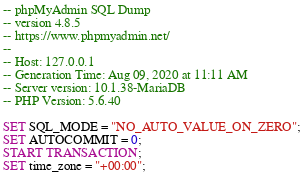<code> <loc_0><loc_0><loc_500><loc_500><_SQL_>-- phpMyAdmin SQL Dump
-- version 4.8.5
-- https://www.phpmyadmin.net/
--
-- Host: 127.0.0.1
-- Generation Time: Aug 09, 2020 at 11:11 AM
-- Server version: 10.1.38-MariaDB
-- PHP Version: 5.6.40

SET SQL_MODE = "NO_AUTO_VALUE_ON_ZERO";
SET AUTOCOMMIT = 0;
START TRANSACTION;
SET time_zone = "+00:00";

</code> 